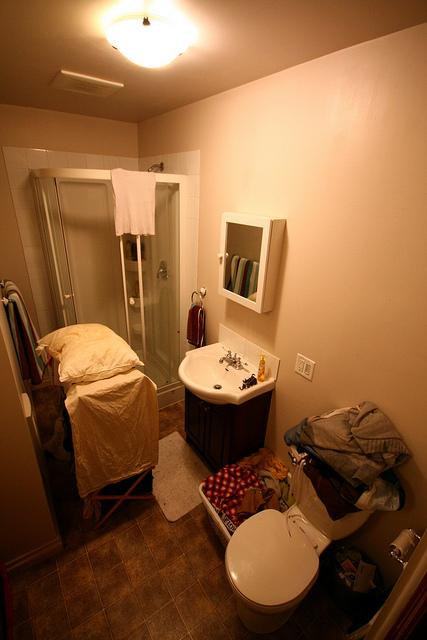What room is this?
Be succinct. Bathroom. What is illuminating the room?
Keep it brief. Light. Where is the pillow?
Write a very short answer. Laundry basket. 